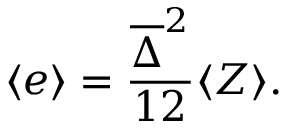<formula> <loc_0><loc_0><loc_500><loc_500>\langle e \rangle = \frac { \overline { \Delta } ^ { 2 } } { 1 2 } \langle Z \rangle .</formula> 